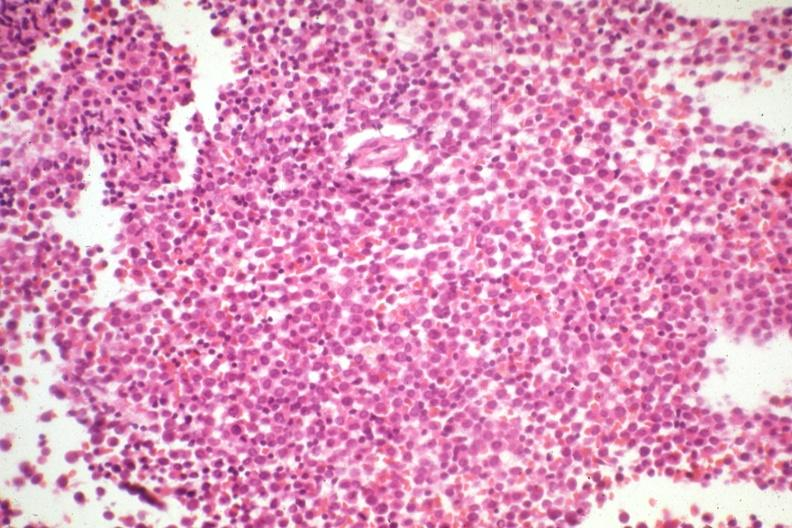s cystadenocarcinoma malignancy present?
Answer the question using a single word or phrase. No 